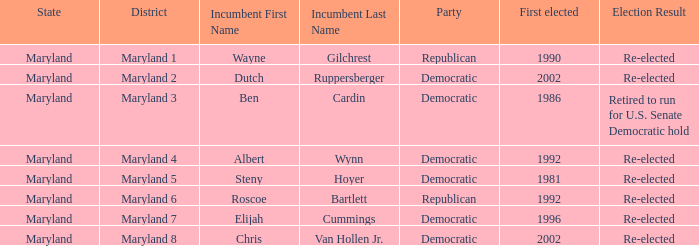What are the results of the incumbent who was first elected in 1996? Re-elected. 